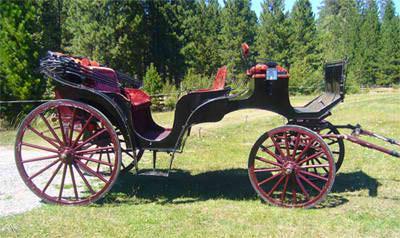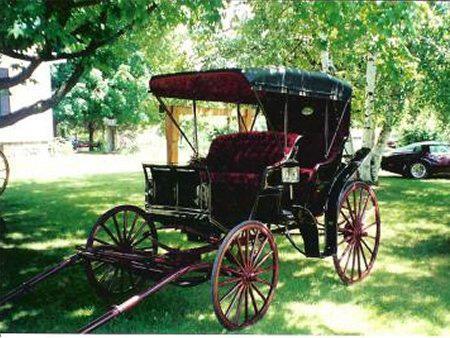The first image is the image on the left, the second image is the image on the right. For the images shown, is this caption "At least one of the carriages has wheels with red spokes." true? Answer yes or no. Yes. The first image is the image on the left, the second image is the image on the right. Examine the images to the left and right. Is the description "An image shows a wagon with violet interior and a dark top over it." accurate? Answer yes or no. Yes. 